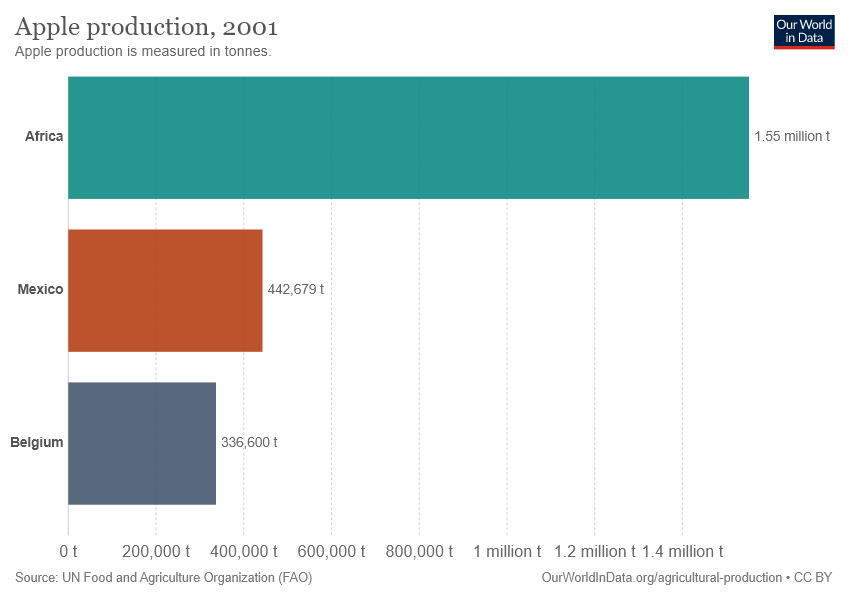Outline some significant characteristics in this image. The region with the highest production of apples is Africa. The value of Apple production in Mexico is greater than in Belgium. 